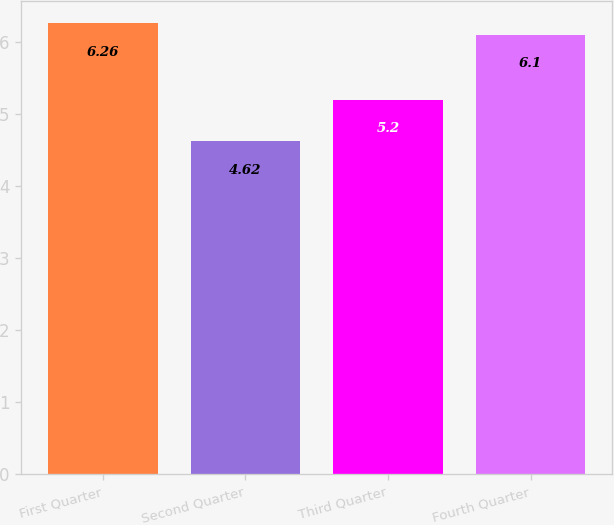Convert chart. <chart><loc_0><loc_0><loc_500><loc_500><bar_chart><fcel>First Quarter<fcel>Second Quarter<fcel>Third Quarter<fcel>Fourth Quarter<nl><fcel>6.26<fcel>4.62<fcel>5.2<fcel>6.1<nl></chart> 